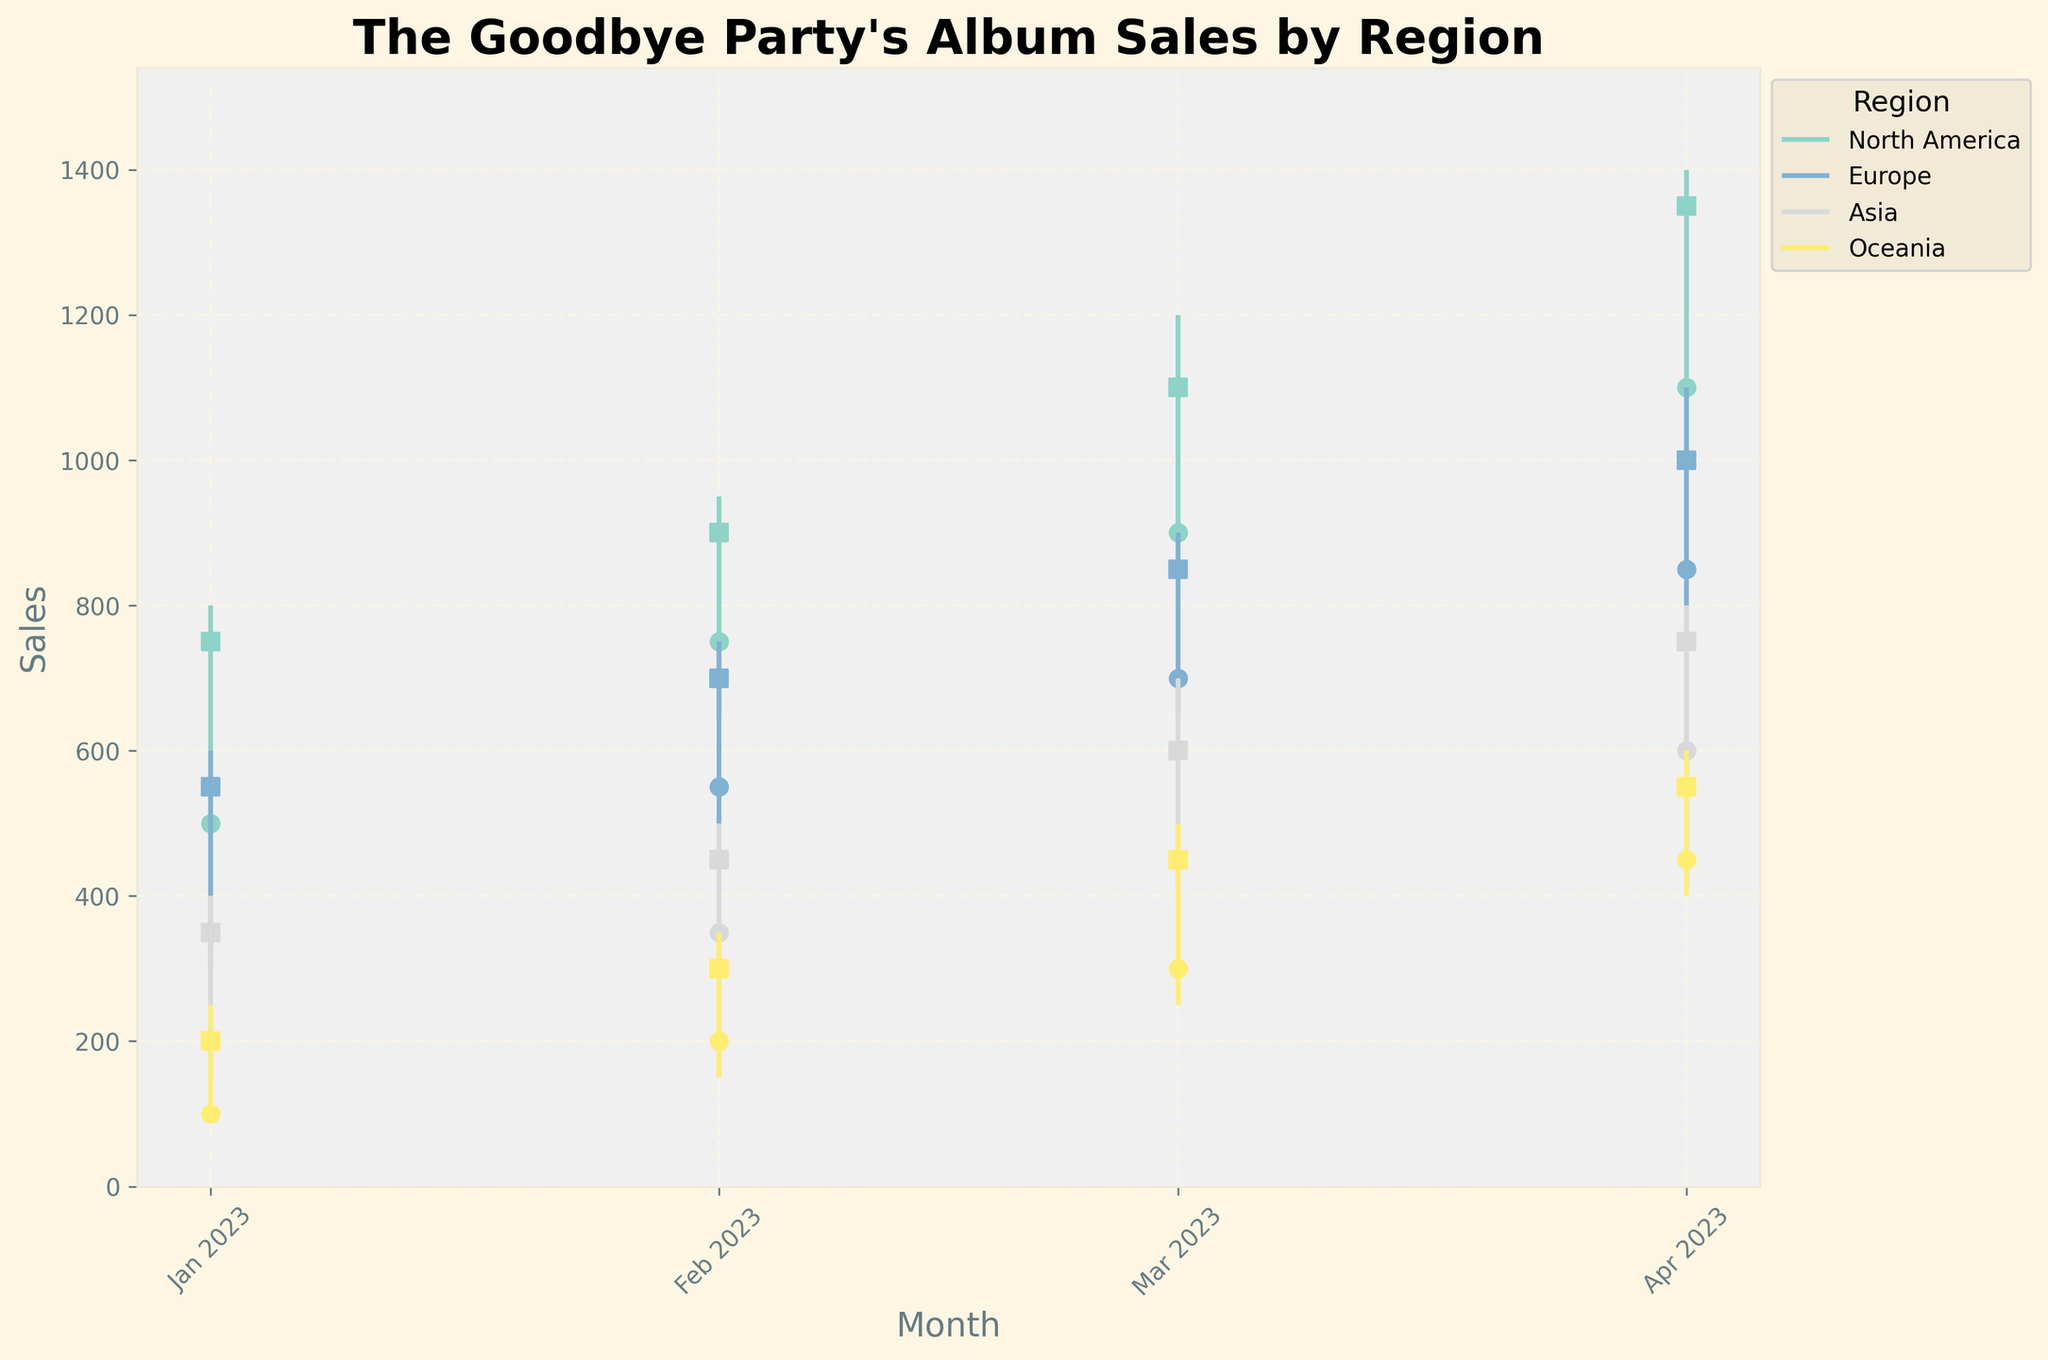How many regions are represented in the figure? The number of different colors/labels in the figure corresponds to the number of regions. By counting the unique colors/labels, we determine the number of regions represented.
Answer: 4 What is the title of the figure? The title is displayed prominently at the top of the figure.
Answer: "The Goodbye Party's Album Sales by Region" Which region had the highest sales in March 2023? By looking at the highest data point (the High value) for each region in March 2023, we find which region had the highest sales.
Answer: North America What was the trend in sales for Europe from January to April 2023? By comparing the Close values for Europe from January to April 2023, we see a clear upward trend.
Answer: Increasing Compare the opening sales for North America and Asia in April 2023. Which was higher? By looking at the Open values for North America and Asia in April 2023, we compare the two values. North America had an opening sale of 1100, whereas Asia had 600.
Answer: North America What is the range of sales for Oceania in February 2023? The range is calculated by subtracting the Low value from the High value for Oceania in February 2023. This is 350 (High) - 150 (Low).
Answer: 200 What was the total sum of Close values for Europe across all months? To get the total sum of Close values for Europe, add the Close values for January (550), February (700), March (850), and April (1000).
Answer: 3100 Which month had the lowest Low value for Asia, and what was that value? By examining the Low values for Asia across all months, the lowest Low value occurred in January 2023 with a value of 150.
Answer: January 2023, 150 Between North America and Europe, which region had more stability in sales in April 2023? Sales stability can be interpreted by the difference between High and Low values. North America's range is (1400 - 1000 = 400) and Europe's range is (1100 - 800 = 300). Europe displayed more stable sales with a smaller range.
Answer: Europe What is the average High value for North America from January to April 2023? Calculate the average by adding the High values for January (800), February (950), March (1200), and April (1400) and dividing by 4. (800 + 950 + 1200 + 1400) / 4 = 1087.5
Answer: 1087.5 